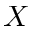<formula> <loc_0><loc_0><loc_500><loc_500>X</formula> 